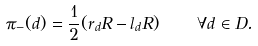<formula> <loc_0><loc_0><loc_500><loc_500>\pi _ { - } ( d ) = \frac { 1 } { 2 } ( r _ { d } R - l _ { d } R ) \quad \forall d \in D .</formula> 